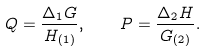<formula> <loc_0><loc_0><loc_500><loc_500>Q = \frac { \Delta _ { 1 } G } { H _ { ( 1 ) } } , \quad P = \frac { \Delta _ { 2 } H } { G _ { ( 2 ) } } .</formula> 